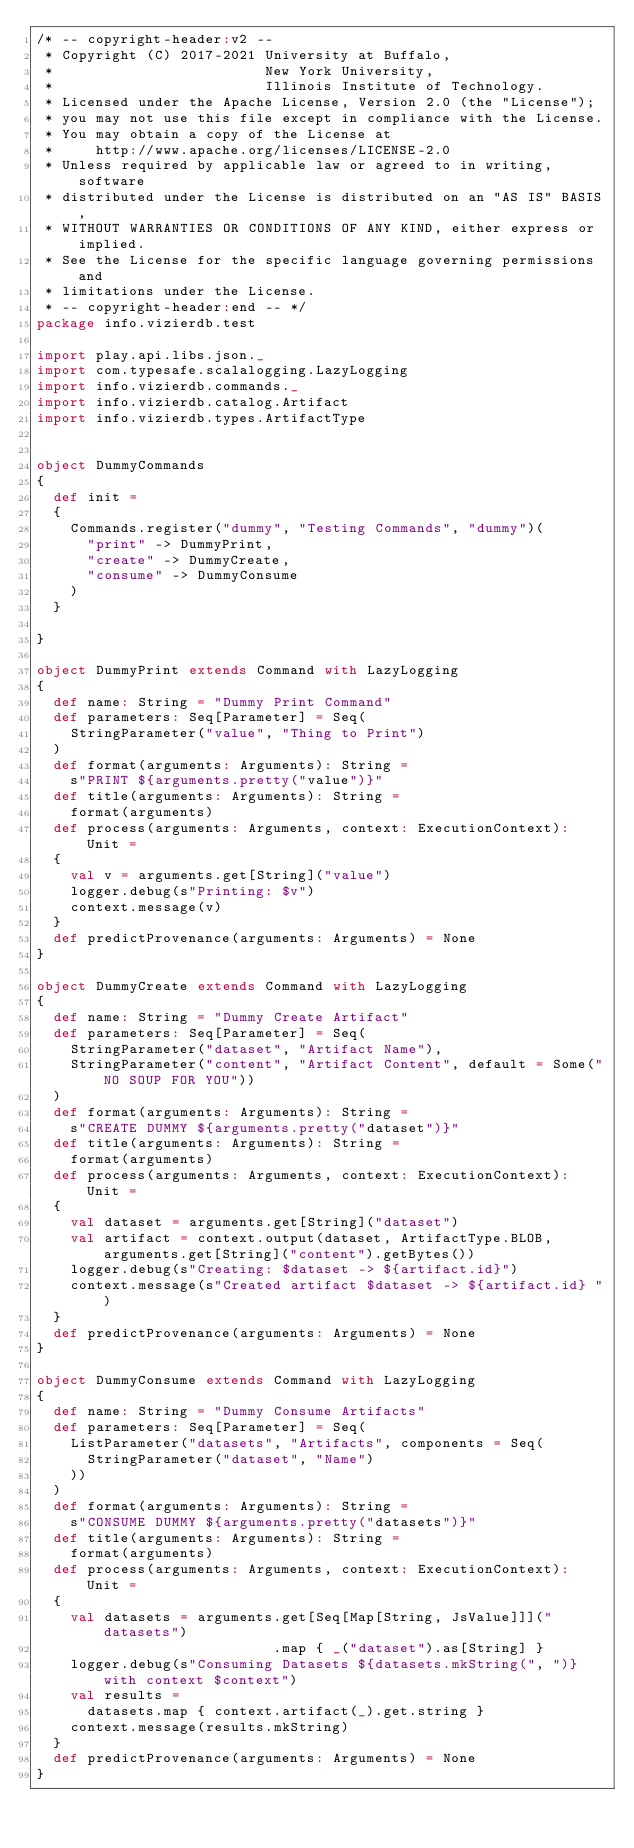<code> <loc_0><loc_0><loc_500><loc_500><_Scala_>/* -- copyright-header:v2 --
 * Copyright (C) 2017-2021 University at Buffalo,
 *                         New York University,
 *                         Illinois Institute of Technology.
 * Licensed under the Apache License, Version 2.0 (the "License");
 * you may not use this file except in compliance with the License.
 * You may obtain a copy of the License at
 *     http://www.apache.org/licenses/LICENSE-2.0
 * Unless required by applicable law or agreed to in writing, software
 * distributed under the License is distributed on an "AS IS" BASIS,
 * WITHOUT WARRANTIES OR CONDITIONS OF ANY KIND, either express or implied.
 * See the License for the specific language governing permissions and
 * limitations under the License.
 * -- copyright-header:end -- */
package info.vizierdb.test

import play.api.libs.json._
import com.typesafe.scalalogging.LazyLogging
import info.vizierdb.commands._
import info.vizierdb.catalog.Artifact
import info.vizierdb.types.ArtifactType


object DummyCommands 
{
  def init =
  {
    Commands.register("dummy", "Testing Commands", "dummy")(
      "print" -> DummyPrint,
      "create" -> DummyCreate,
      "consume" -> DummyConsume
    )
  }

}

object DummyPrint extends Command with LazyLogging
{
  def name: String = "Dummy Print Command"
  def parameters: Seq[Parameter] = Seq(
    StringParameter("value", "Thing to Print")
  )
  def format(arguments: Arguments): String = 
    s"PRINT ${arguments.pretty("value")}"
  def title(arguments: Arguments): String = 
    format(arguments)
  def process(arguments: Arguments, context: ExecutionContext): Unit = 
  {
    val v = arguments.get[String]("value")
    logger.debug(s"Printing: $v")
    context.message(v)
  }
  def predictProvenance(arguments: Arguments) = None
}

object DummyCreate extends Command with LazyLogging
{
  def name: String = "Dummy Create Artifact"
  def parameters: Seq[Parameter] = Seq(
    StringParameter("dataset", "Artifact Name"),
    StringParameter("content", "Artifact Content", default = Some("NO SOUP FOR YOU"))
  )
  def format(arguments: Arguments): String = 
    s"CREATE DUMMY ${arguments.pretty("dataset")}"
  def title(arguments: Arguments): String = 
    format(arguments)
  def process(arguments: Arguments, context: ExecutionContext): Unit = 
  {
    val dataset = arguments.get[String]("dataset") 
    val artifact = context.output(dataset, ArtifactType.BLOB, arguments.get[String]("content").getBytes())
    logger.debug(s"Creating: $dataset -> ${artifact.id}")
    context.message(s"Created artifact $dataset -> ${artifact.id} ")
  }
  def predictProvenance(arguments: Arguments) = None
}

object DummyConsume extends Command with LazyLogging
{
  def name: String = "Dummy Consume Artifacts"
  def parameters: Seq[Parameter] = Seq(
    ListParameter("datasets", "Artifacts", components = Seq(
      StringParameter("dataset", "Name")
    ))
  )
  def format(arguments: Arguments): String = 
    s"CONSUME DUMMY ${arguments.pretty("datasets")}"
  def title(arguments: Arguments): String = 
    format(arguments)
  def process(arguments: Arguments, context: ExecutionContext): Unit = 
  {
    val datasets = arguments.get[Seq[Map[String, JsValue]]]("datasets")
                            .map { _("dataset").as[String] }
    logger.debug(s"Consuming Datasets ${datasets.mkString(", ")} with context $context")
    val results = 
      datasets.map { context.artifact(_).get.string }  
    context.message(results.mkString)
  }
  def predictProvenance(arguments: Arguments) = None
}

</code> 